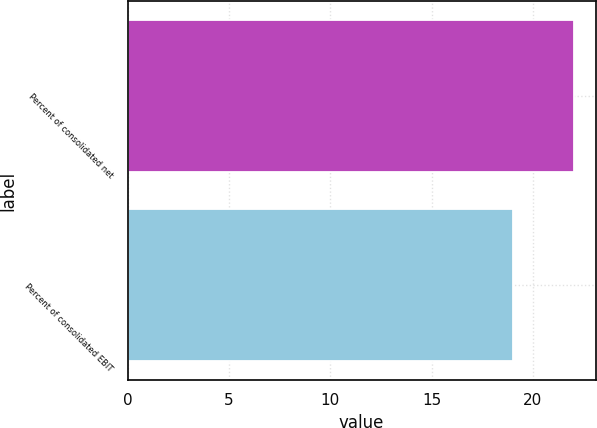Convert chart. <chart><loc_0><loc_0><loc_500><loc_500><bar_chart><fcel>Percent of consolidated net<fcel>Percent of consolidated EBIT<nl><fcel>22<fcel>19<nl></chart> 